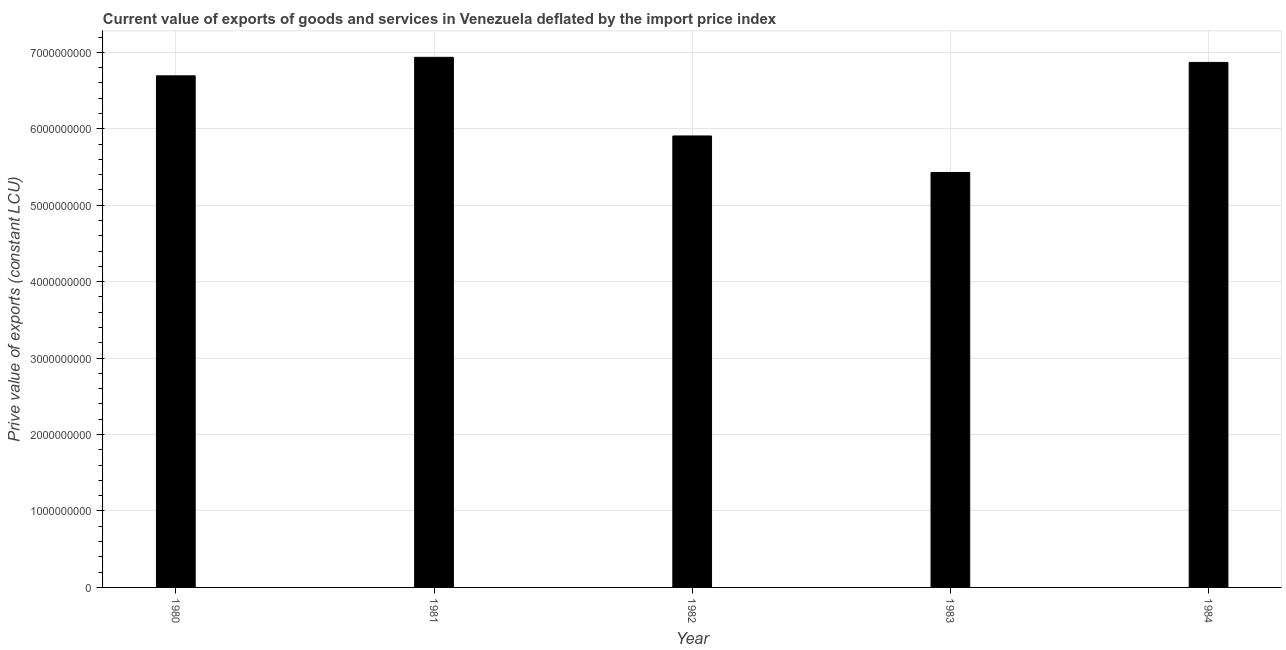What is the title of the graph?
Ensure brevity in your answer.  Current value of exports of goods and services in Venezuela deflated by the import price index. What is the label or title of the Y-axis?
Ensure brevity in your answer.  Prive value of exports (constant LCU). What is the price value of exports in 1983?
Offer a terse response. 5.43e+09. Across all years, what is the maximum price value of exports?
Your response must be concise. 6.93e+09. Across all years, what is the minimum price value of exports?
Ensure brevity in your answer.  5.43e+09. What is the sum of the price value of exports?
Give a very brief answer. 3.18e+1. What is the difference between the price value of exports in 1982 and 1984?
Make the answer very short. -9.62e+08. What is the average price value of exports per year?
Your answer should be compact. 6.37e+09. What is the median price value of exports?
Your answer should be very brief. 6.69e+09. Do a majority of the years between 1984 and 1981 (inclusive) have price value of exports greater than 200000000 LCU?
Provide a succinct answer. Yes. What is the ratio of the price value of exports in 1981 to that in 1983?
Keep it short and to the point. 1.28. Is the price value of exports in 1981 less than that in 1983?
Provide a succinct answer. No. What is the difference between the highest and the second highest price value of exports?
Ensure brevity in your answer.  6.65e+07. Is the sum of the price value of exports in 1980 and 1984 greater than the maximum price value of exports across all years?
Give a very brief answer. Yes. What is the difference between the highest and the lowest price value of exports?
Ensure brevity in your answer.  1.51e+09. How many bars are there?
Your answer should be compact. 5. Are all the bars in the graph horizontal?
Offer a terse response. No. How many years are there in the graph?
Offer a terse response. 5. What is the Prive value of exports (constant LCU) of 1980?
Keep it short and to the point. 6.69e+09. What is the Prive value of exports (constant LCU) of 1981?
Offer a terse response. 6.93e+09. What is the Prive value of exports (constant LCU) of 1982?
Ensure brevity in your answer.  5.91e+09. What is the Prive value of exports (constant LCU) of 1983?
Ensure brevity in your answer.  5.43e+09. What is the Prive value of exports (constant LCU) in 1984?
Your response must be concise. 6.87e+09. What is the difference between the Prive value of exports (constant LCU) in 1980 and 1981?
Offer a very short reply. -2.42e+08. What is the difference between the Prive value of exports (constant LCU) in 1980 and 1982?
Provide a short and direct response. 7.87e+08. What is the difference between the Prive value of exports (constant LCU) in 1980 and 1983?
Offer a very short reply. 1.26e+09. What is the difference between the Prive value of exports (constant LCU) in 1980 and 1984?
Your answer should be very brief. -1.75e+08. What is the difference between the Prive value of exports (constant LCU) in 1981 and 1982?
Give a very brief answer. 1.03e+09. What is the difference between the Prive value of exports (constant LCU) in 1981 and 1983?
Give a very brief answer. 1.51e+09. What is the difference between the Prive value of exports (constant LCU) in 1981 and 1984?
Keep it short and to the point. 6.65e+07. What is the difference between the Prive value of exports (constant LCU) in 1982 and 1983?
Keep it short and to the point. 4.78e+08. What is the difference between the Prive value of exports (constant LCU) in 1982 and 1984?
Your response must be concise. -9.62e+08. What is the difference between the Prive value of exports (constant LCU) in 1983 and 1984?
Keep it short and to the point. -1.44e+09. What is the ratio of the Prive value of exports (constant LCU) in 1980 to that in 1981?
Provide a short and direct response. 0.96. What is the ratio of the Prive value of exports (constant LCU) in 1980 to that in 1982?
Make the answer very short. 1.13. What is the ratio of the Prive value of exports (constant LCU) in 1980 to that in 1983?
Your answer should be very brief. 1.23. What is the ratio of the Prive value of exports (constant LCU) in 1981 to that in 1982?
Your answer should be compact. 1.17. What is the ratio of the Prive value of exports (constant LCU) in 1981 to that in 1983?
Your response must be concise. 1.28. What is the ratio of the Prive value of exports (constant LCU) in 1982 to that in 1983?
Your response must be concise. 1.09. What is the ratio of the Prive value of exports (constant LCU) in 1982 to that in 1984?
Your answer should be very brief. 0.86. What is the ratio of the Prive value of exports (constant LCU) in 1983 to that in 1984?
Give a very brief answer. 0.79. 